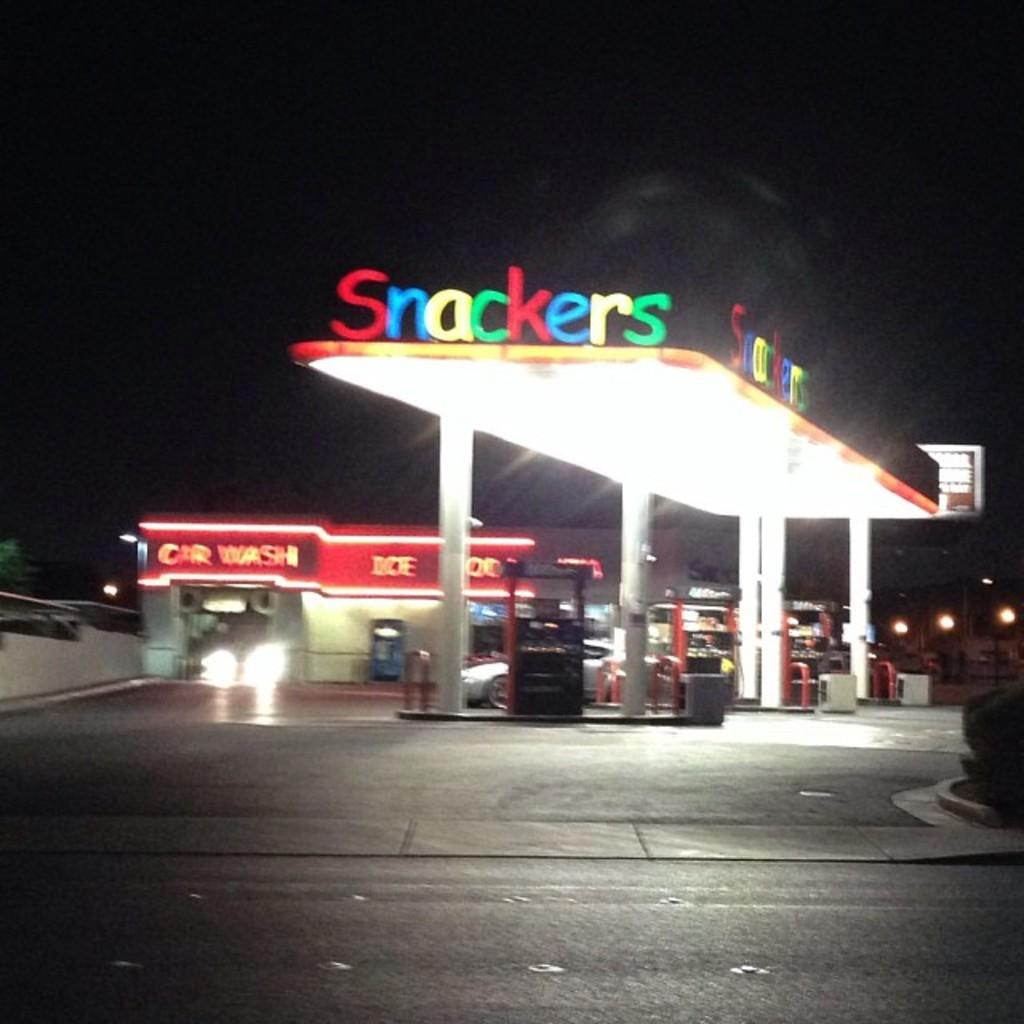What type of establishment is shown in the image? There is a filling station in the image. Can you describe the background of the image? The background of the image is dark. What type of soup is being served at the filling station in the image? There is no soup present in the image, as it features a filling station. Who is the creator of the filling station in the image? The creator of the filling station is not visible or identifiable in the image. 